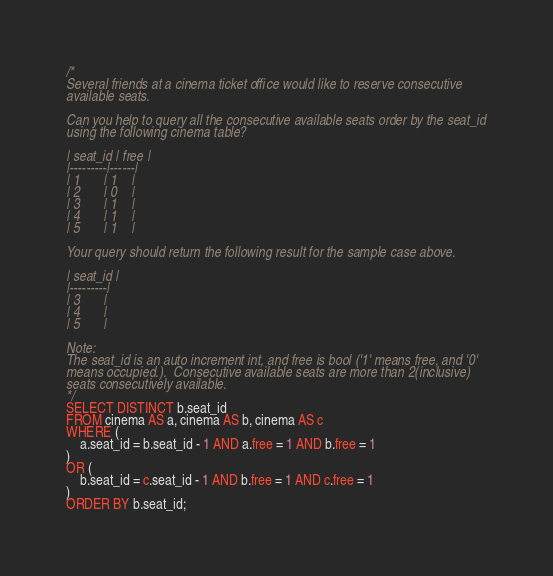Convert code to text. <code><loc_0><loc_0><loc_500><loc_500><_SQL_>/*
Several friends at a cinema ticket office would like to reserve consecutive
available seats.

Can you help to query all the consecutive available seats order by the seat_id
using the following cinema table?

| seat_id | free |
|---------|------|
| 1       | 1    |
| 2       | 0    |
| 3       | 1    |
| 4       | 1    |
| 5       | 1    |

Your query should return the following result for the sample case above.

| seat_id |
|---------|
| 3       |
| 4       |
| 5       |

Note:
The seat_id is an auto increment int, and free is bool ('1' means free, and '0'
means occupied.).  Consecutive available seats are more than 2(inclusive)
seats consecutively available.
*/
SELECT DISTINCT b.seat_id
FROM cinema AS a, cinema AS b, cinema AS c
WHERE (
    a.seat_id = b.seat_id - 1 AND a.free = 1 AND b.free = 1
) 
OR (
    b.seat_id = c.seat_id - 1 AND b.free = 1 AND c.free = 1
)
ORDER BY b.seat_id;
</code> 